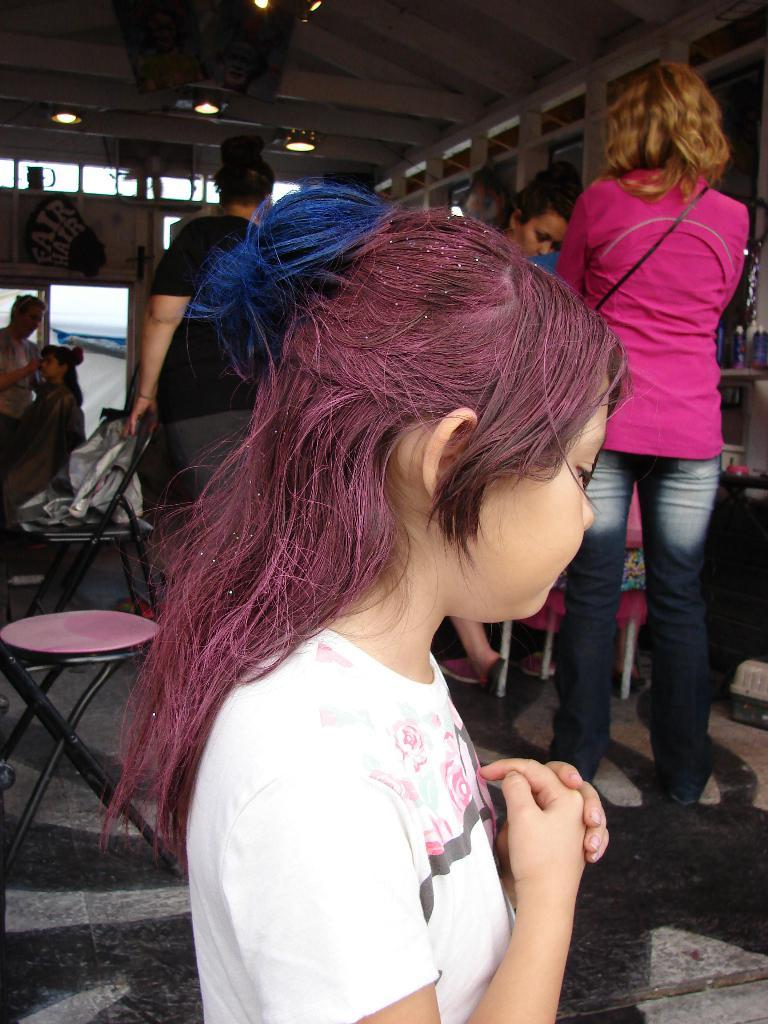Who or what can be seen in the image? There are people in the image. What are the people sitting on? There are chairs in the image for the people to sit on. What can be seen illuminating the scene? There are lights in the image. What is present on a surface in the image? There are objects on a table in the image. Where are the chickens located in the image? There are no chickens present in the image. What type of ship can be seen sailing in the background of the image? There is no ship visible in the image; it only features people, chairs, lights, and objects on a table. 